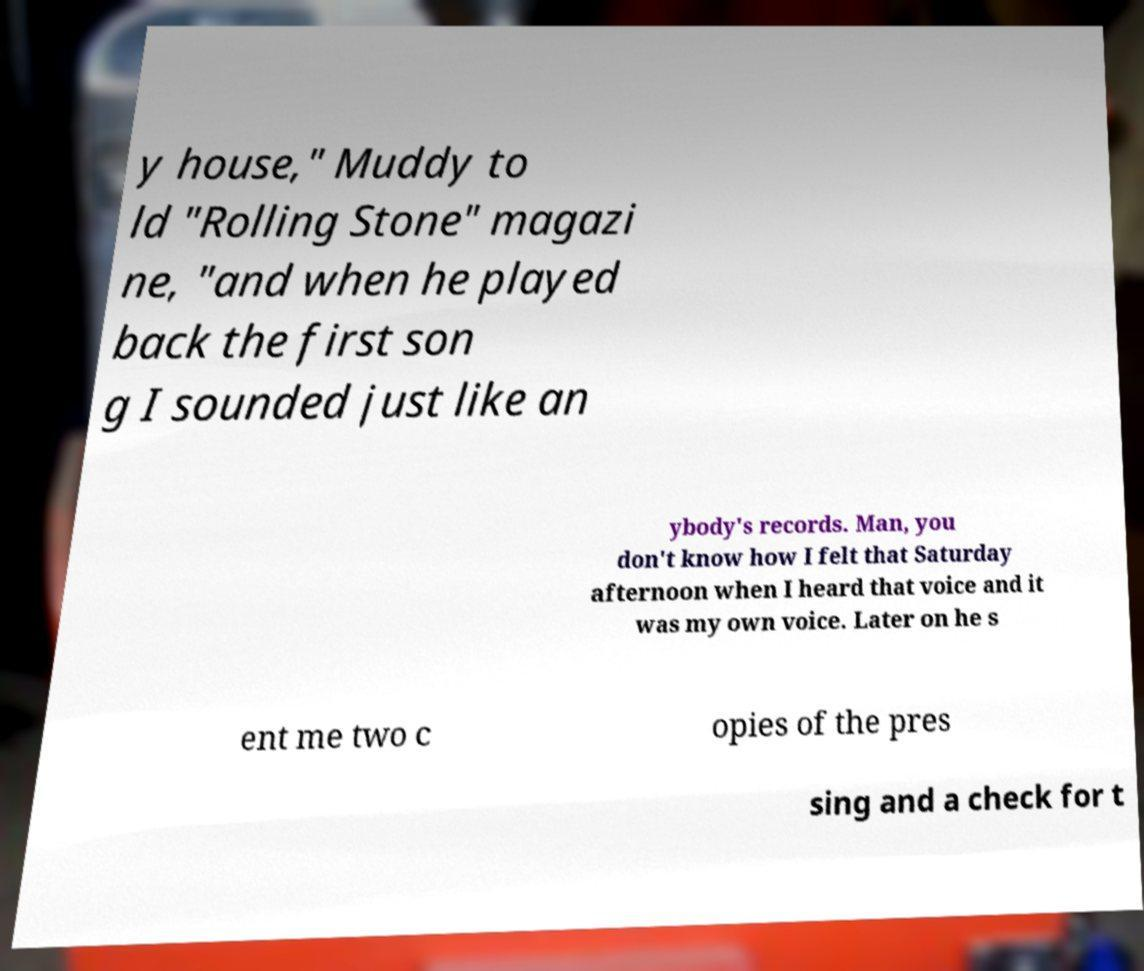For documentation purposes, I need the text within this image transcribed. Could you provide that? y house," Muddy to ld "Rolling Stone" magazi ne, "and when he played back the first son g I sounded just like an ybody's records. Man, you don't know how I felt that Saturday afternoon when I heard that voice and it was my own voice. Later on he s ent me two c opies of the pres sing and a check for t 